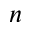<formula> <loc_0><loc_0><loc_500><loc_500>n</formula> 